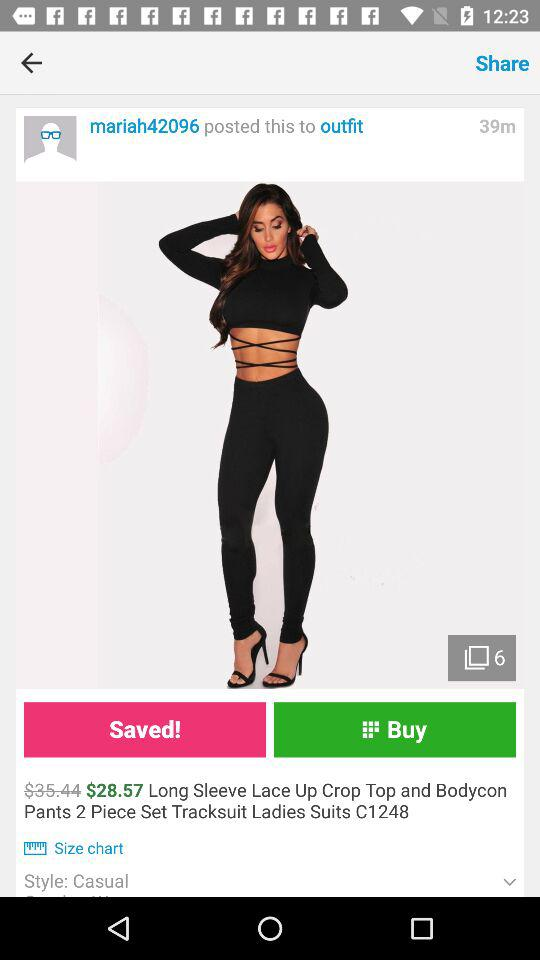How many minutes ago was "Long Sleeve Lace Up Crop Top and Bodycon Pants 2 Piece Set Tracksuit Ladies Suits C1248" posted? "Long Sleeve Lace Up Crop Top and Bodycon Pants 2 Piece Set Tracksuit Ladies Suits C1248" was posted 39 minutes ago. 